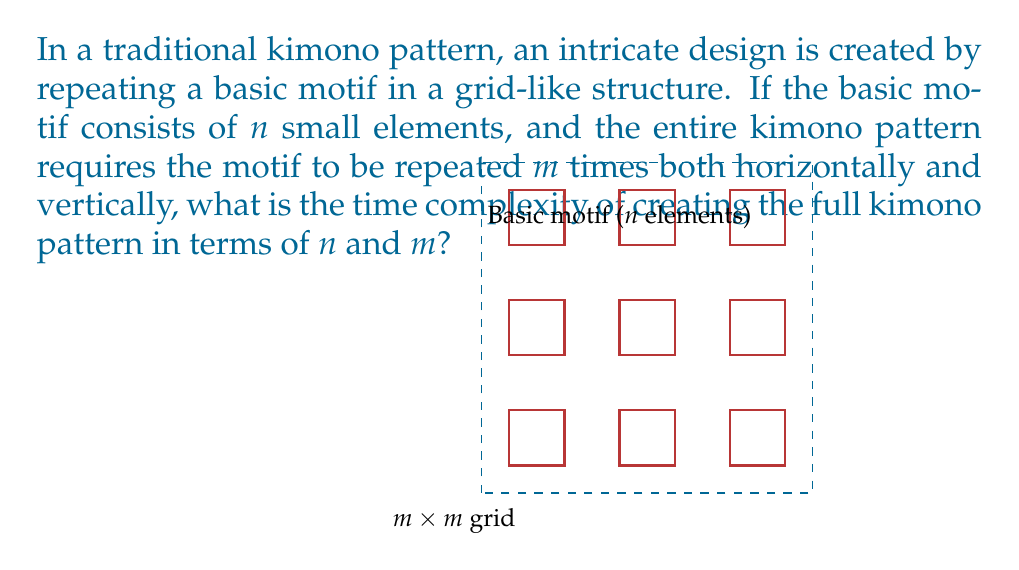Give your solution to this math problem. To analyze the time complexity of creating the kimono pattern, let's break down the process:

1) First, we need to create the basic motif. This requires drawing $n$ elements.
   Time complexity for this step: $O(n)$

2) Next, we need to repeat this motif $m$ times horizontally and $m$ times vertically, creating an $m \times m$ grid.
   This means we're repeating the motif $m^2$ times in total.

3) For each repetition, we're drawing all $n$ elements of the motif.

4) Therefore, the total number of elements drawn is $n \times m^2$.

5) Assuming that drawing each element takes constant time, the overall time complexity is proportional to the number of elements drawn.

Thus, the time complexity of creating the full kimono pattern is $O(nm^2)$.

This quadratic relationship with $m$ reflects the fact that we're filling a two-dimensional area, while the linear relationship with $n$ represents the complexity of the basic motif being repeated.
Answer: $O(nm^2)$ 